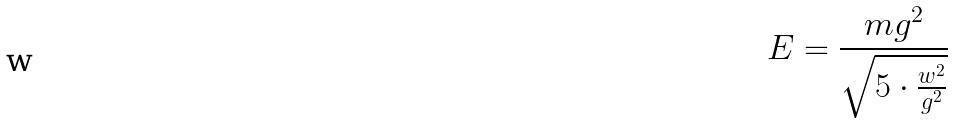<formula> <loc_0><loc_0><loc_500><loc_500>E = \frac { m g ^ { 2 } } { \sqrt { 5 \cdot \frac { w ^ { 2 } } { g ^ { 2 } } } }</formula> 